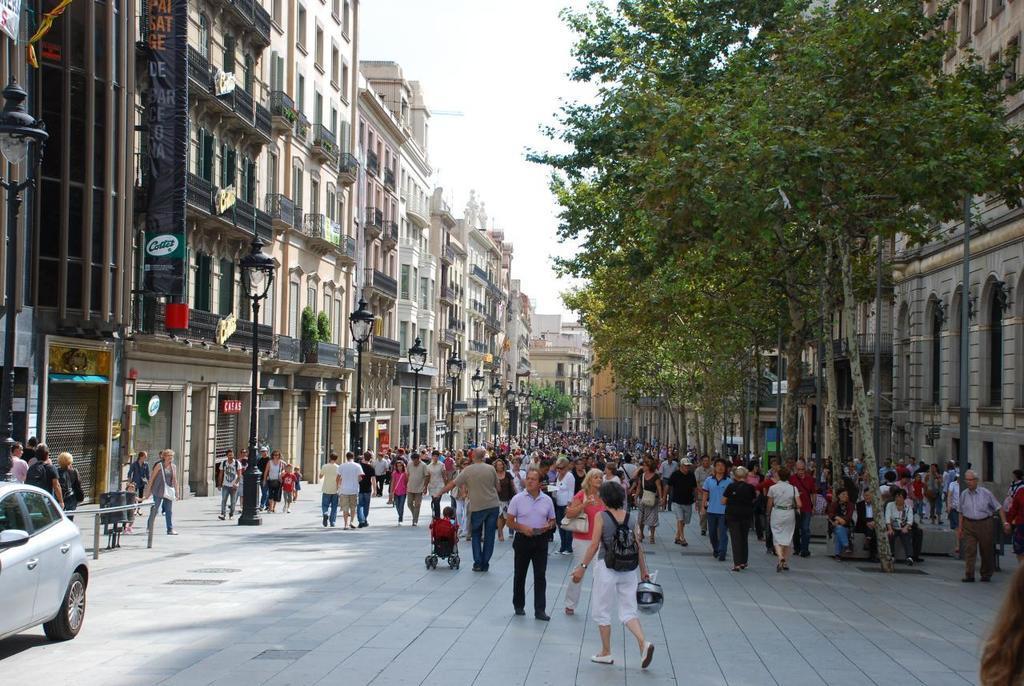Can you describe this image briefly? In this image we can see many buildings, there are windows, there are trees, there are lamps, there are group of persons standing on the ground, there is a pole, there is a car on the road, there is sky at the top. 